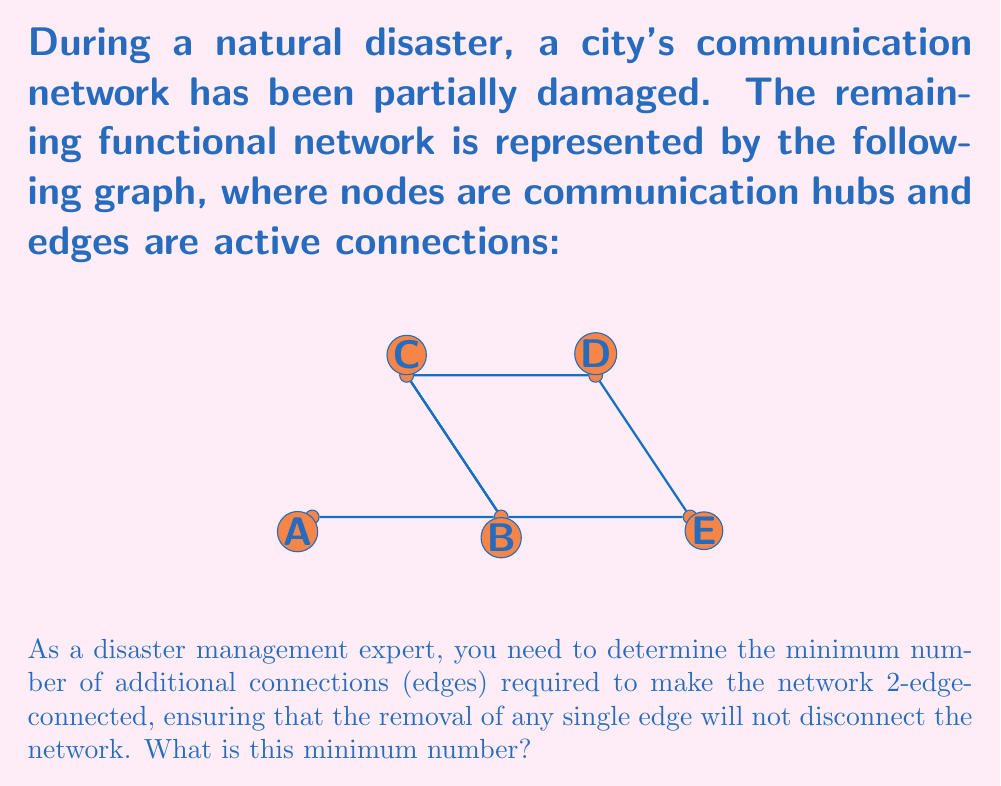Solve this math problem. To solve this problem, we need to understand the concept of 2-edge-connectivity and analyze the given graph:

1. A graph is 2-edge-connected if and only if it remains connected after the removal of any single edge.

2. Analyze the current graph:
   - The graph has 5 vertices (A, B, C, D, E) and 6 edges.
   - It is connected, but not 2-edge-connected.

3. Identify bridges (edges whose removal disconnects the graph):
   - Edge A-B is a bridge: removing it isolates vertex A.
   - Edge D-E is a bridge: removing it isolates vertex E.

4. To make the graph 2-edge-connected, we need to add edges that eliminate these bridges:
   - For A-B: We can add an edge from A to any other vertex (C, D, or E).
   - For D-E: We can add an edge from E to any other vertex (A, B, or C).

5. Minimum solution:
   - Add edge A-C: This eliminates the bridge A-B.
   - Add edge C-E: This eliminates the bridge D-E.

6. After adding these two edges, the graph becomes:

   [asy]
   unitsize(1cm);
   pair A = (0,0), B = (2,0), C = (1,1.5), D = (3,1.5), E = (4,0);
   draw(A--B--C--D--E--B);
   draw(C--B);
   draw(A--C, dashed);
   draw(C--E, dashed);
   dot(A); dot(B); dot(C); dot(D); dot(E);
   label("A", A, SW);
   label("B", B, S);
   label("C", C, N);
   label("D", D, N);
   label("E", E, SE);
   [/asy]

   This graph is now 2-edge-connected, as removing any single edge will not disconnect it.

Therefore, the minimum number of additional connections required is 2.
Answer: 2 